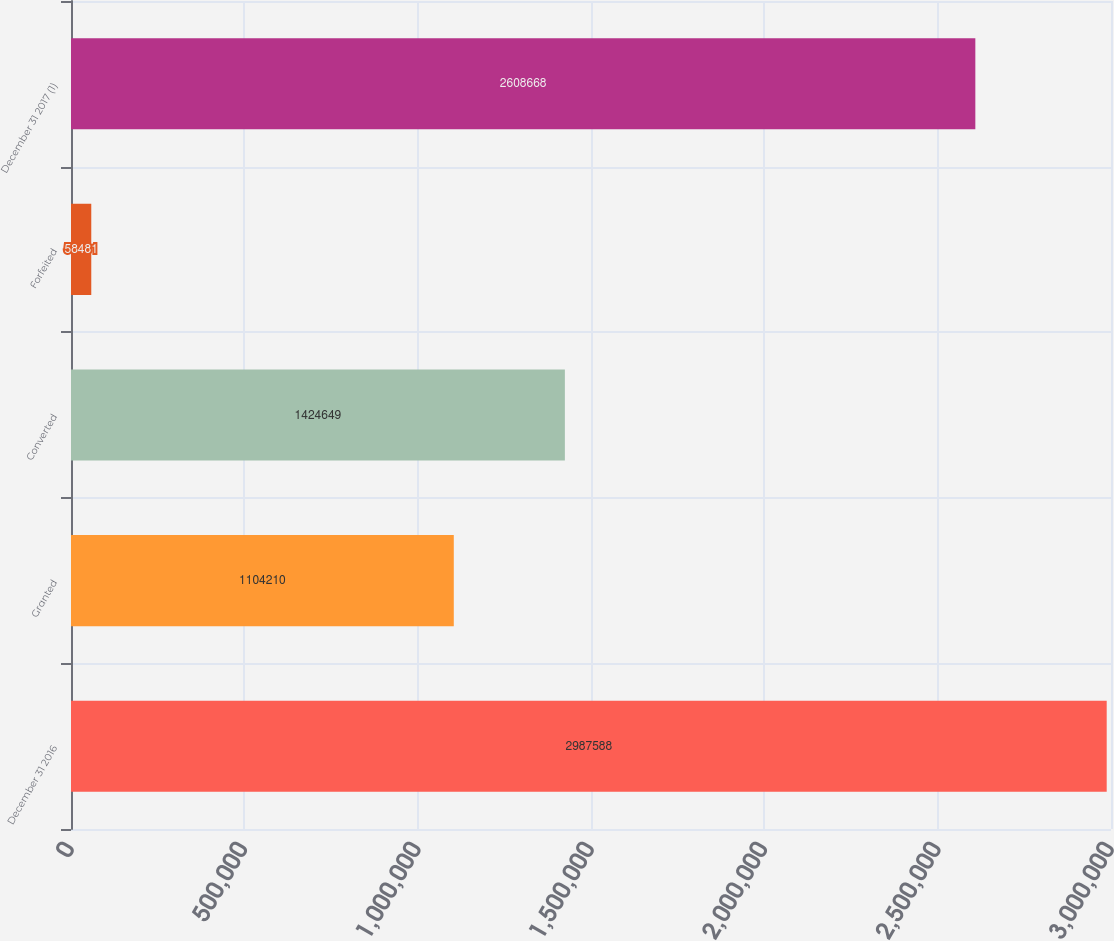Convert chart. <chart><loc_0><loc_0><loc_500><loc_500><bar_chart><fcel>December 31 2016<fcel>Granted<fcel>Converted<fcel>Forfeited<fcel>December 31 2017 (1)<nl><fcel>2.98759e+06<fcel>1.10421e+06<fcel>1.42465e+06<fcel>58481<fcel>2.60867e+06<nl></chart> 